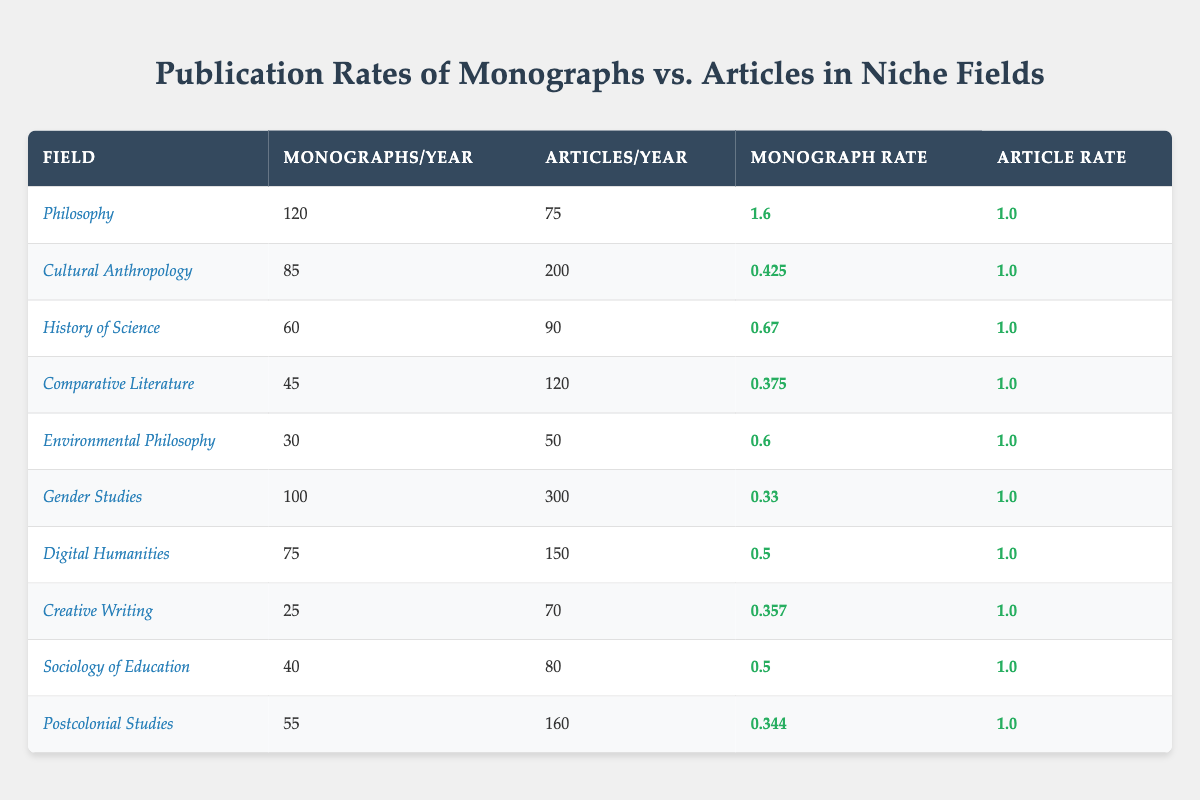What is the publication rate of monographs in Philosophy? The table shows that the publication rate of monographs in Philosophy is 1.6.
Answer: 1.6 How many articles are published per year in Gender Studies? According to the table, Gender Studies has 300 articles published per year.
Answer: 300 Which field has the highest number of articles per year? By examining the table, Cultural Anthropology has the highest number of articles published per year, which is 200.
Answer: Cultural Anthropology What is the difference in the number of monographs published per year between Sociology of Education and Comparative Literature? Sociology of Education publishes 40 monographs per year and Comparative Literature publishes 45. The difference is 45 - 40 = 5.
Answer: 5 In which field is the monograph publication rate the lowest? The field with the lowest monograph publication rate is Gender Studies, with a rate of 0.33.
Answer: Gender Studies What is the average publication rate of articles across all fields? To find the average, add all the article rates together (1.0 for all but Cultural Anthropology, which is 1.0 as well) summing to 10, then divide by the number of fields (10) to get the average rate as 1.0.
Answer: 1.0 Is it true that the number of monographs published in Environmental Philosophy is greater than 40? The table indicates that Environmental Philosophy has 30 monographs published per year, which is less than 40, so the statement is false.
Answer: No Which field has a higher monograph publication rate: Digital Humanities or History of Science? Digital Humanities has a monograph rate of 0.5, while History of Science has a rate of 0.67. Since 0.67 is higher, History of Science has the higher monograph publication rate.
Answer: History of Science If you combine the annual monograph publications of Creative Writing and Environmental Philosophy, what would that total be? The table states that Creative Writing publishes 25 monographs and Environmental Philosophy publishes 30. Therefore, the total is 25 + 30 = 55.
Answer: 55 How many more articles are published per year in Sociology of Education than in Environmental Philosophy? Sociology of Education publishes 80 articles and Environmental Philosophy publishes 50. The difference is 80 - 50 = 30 articles.
Answer: 30 